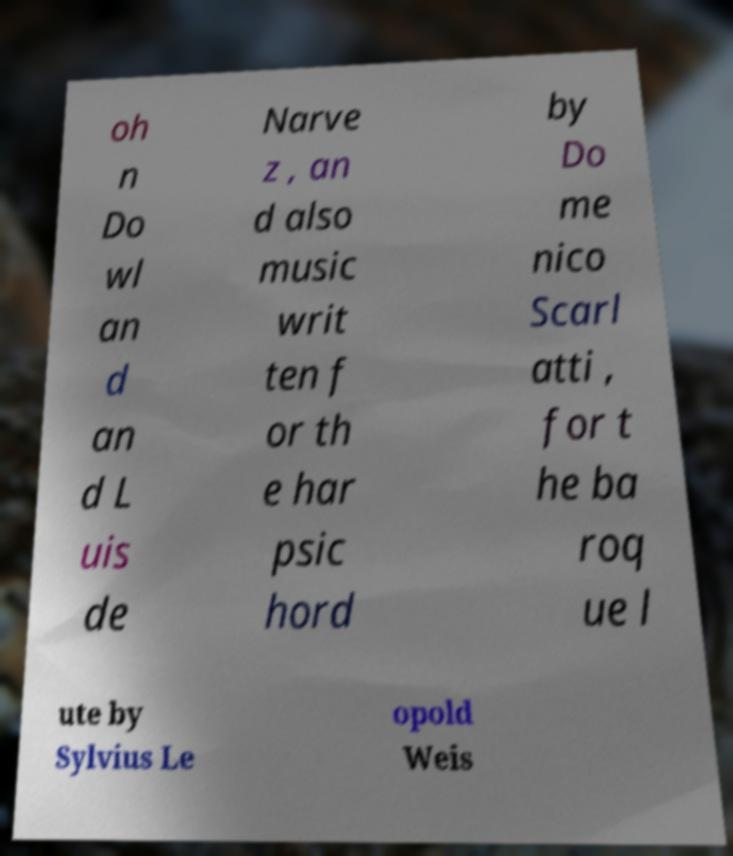I need the written content from this picture converted into text. Can you do that? oh n Do wl an d an d L uis de Narve z , an d also music writ ten f or th e har psic hord by Do me nico Scarl atti , for t he ba roq ue l ute by Sylvius Le opold Weis 